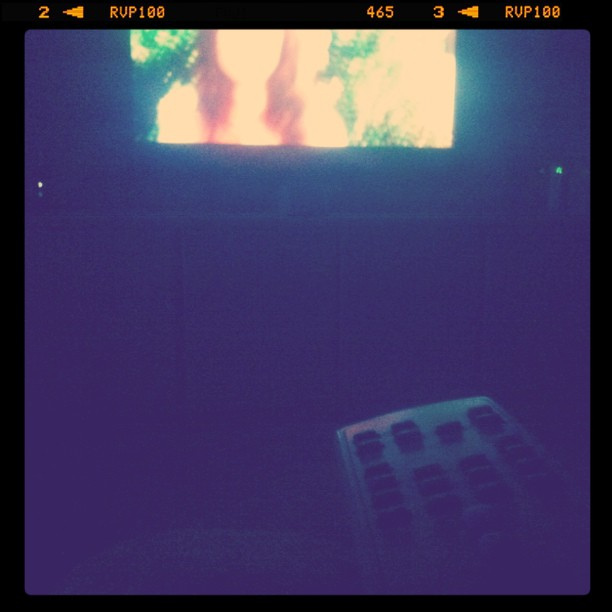<image>What companion object to the TV can be seen in the bottom right of the picture? I am not completely sure which object is in the bottom right of the picture, possibly it can be a remote. What companion object to the TV can be seen in the bottom right of the picture? I am not sure what companion object to the TV can be seen in the bottom right of the picture. It can be a TV remote or a remote control. 